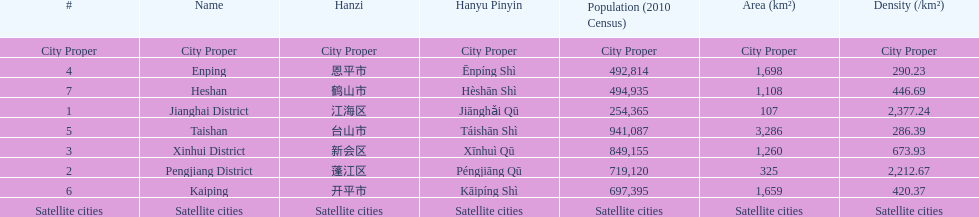Which area has the largest population? Taishan. 